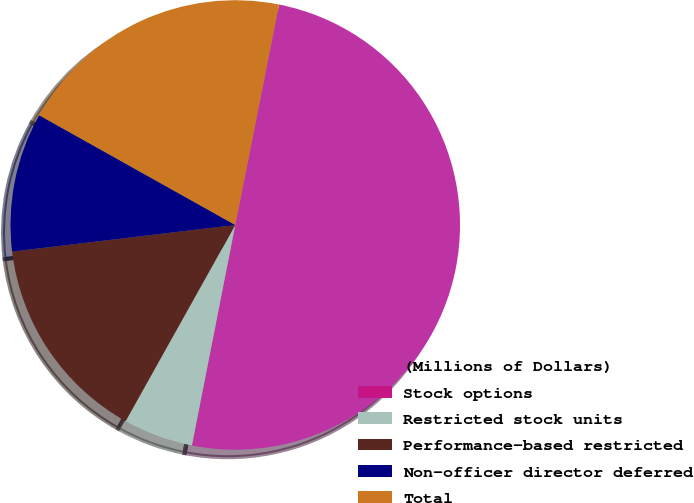Convert chart to OTSL. <chart><loc_0><loc_0><loc_500><loc_500><pie_chart><fcel>(Millions of Dollars)<fcel>Stock options<fcel>Restricted stock units<fcel>Performance-based restricted<fcel>Non-officer director deferred<fcel>Total<nl><fcel>49.95%<fcel>0.02%<fcel>5.02%<fcel>15.0%<fcel>10.01%<fcel>20.0%<nl></chart> 